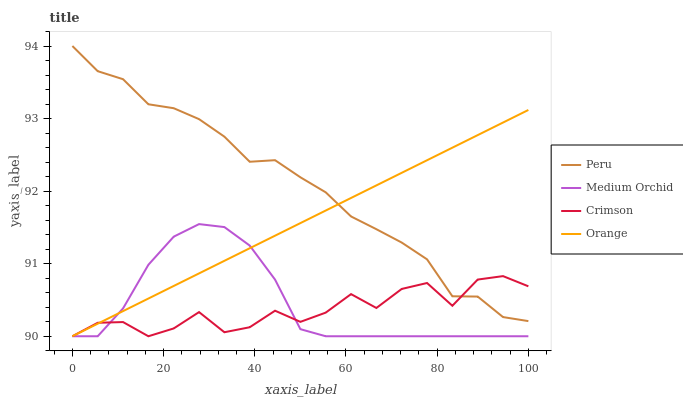Does Orange have the minimum area under the curve?
Answer yes or no. No. Does Orange have the maximum area under the curve?
Answer yes or no. No. Is Medium Orchid the smoothest?
Answer yes or no. No. Is Medium Orchid the roughest?
Answer yes or no. No. Does Peru have the lowest value?
Answer yes or no. No. Does Orange have the highest value?
Answer yes or no. No. Is Medium Orchid less than Peru?
Answer yes or no. Yes. Is Peru greater than Medium Orchid?
Answer yes or no. Yes. Does Medium Orchid intersect Peru?
Answer yes or no. No. 